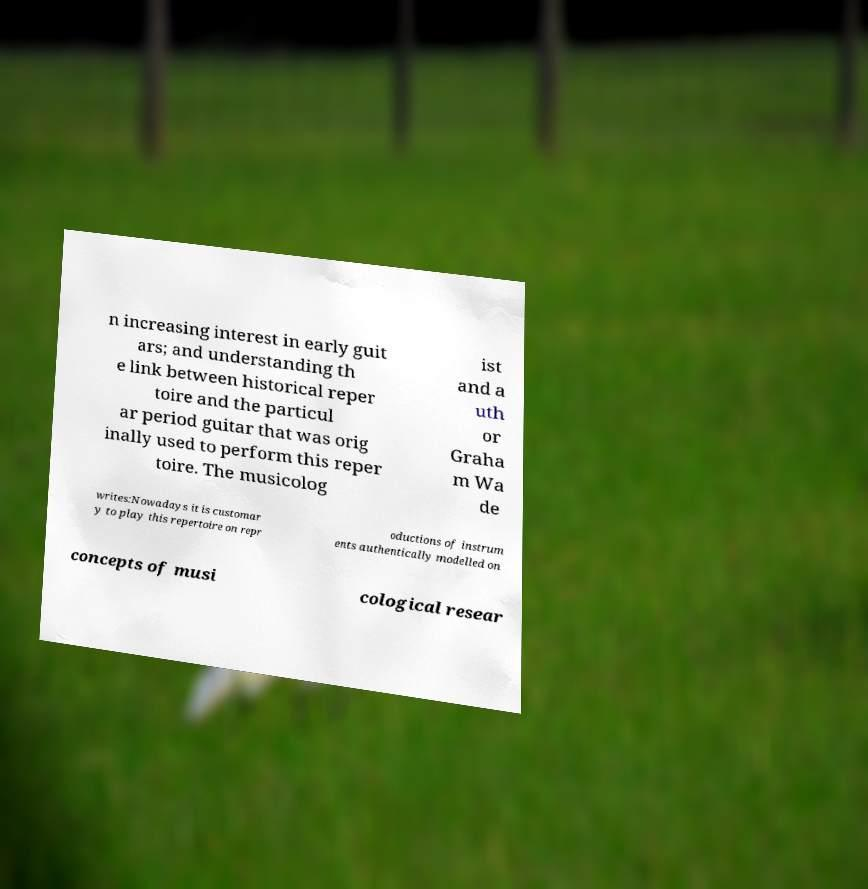Can you accurately transcribe the text from the provided image for me? n increasing interest in early guit ars; and understanding th e link between historical reper toire and the particul ar period guitar that was orig inally used to perform this reper toire. The musicolog ist and a uth or Graha m Wa de writes:Nowadays it is customar y to play this repertoire on repr oductions of instrum ents authentically modelled on concepts of musi cological resear 